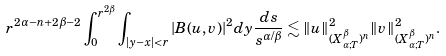Convert formula to latex. <formula><loc_0><loc_0><loc_500><loc_500>r ^ { 2 \alpha - n + 2 \beta - 2 } \int _ { 0 } ^ { r ^ { 2 \beta } } \int _ { | y - x | < r } | B ( u , v ) | ^ { 2 } d y \frac { d s } { s ^ { \alpha / \beta } } \lesssim \| u \| ^ { 2 } _ { ( X _ { \alpha ; T } ^ { \beta } ) ^ { n } } \| v \| ^ { 2 } _ { ( X _ { \alpha ; T } ^ { \beta } ) ^ { n } } .</formula> 